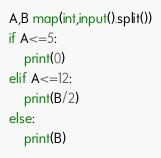Convert code to text. <code><loc_0><loc_0><loc_500><loc_500><_Python_>A,B map(int,input().split())
if A<=5:
    print(0)
elif A<=12:
    print(B/2)
else:
    print(B)</code> 